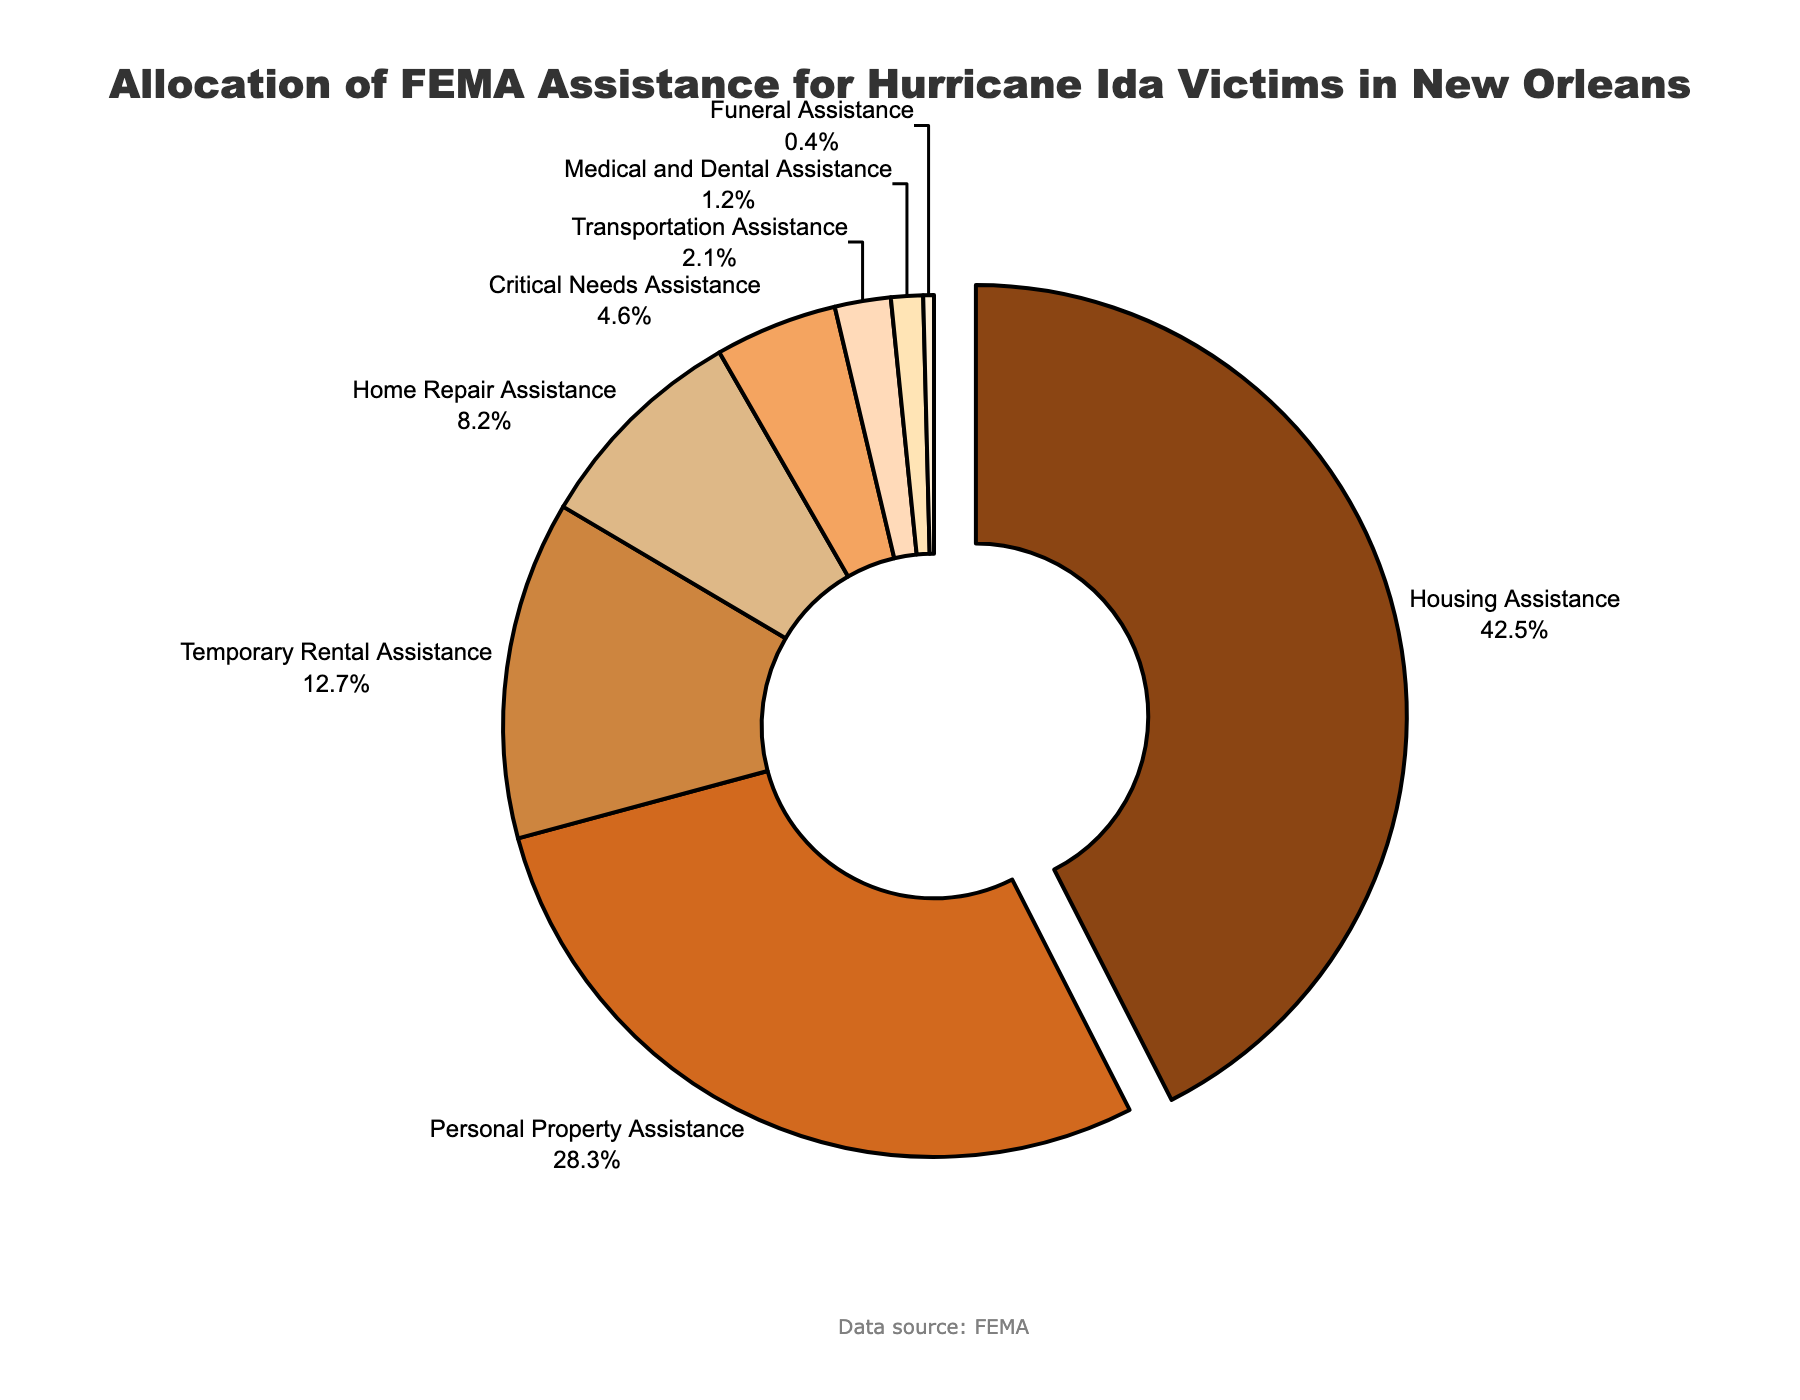What category receives the highest percentage of FEMA assistance? According to the pie chart, the segment with the highest percentage is labeled "Housing Assistance."
Answer: Housing Assistance How much more percentage of FEMA assistance does Personal Property Assistance receive compared to Home Repair Assistance? From the chart, Personal Property Assistance receives 28.3%, and Home Repair Assistance receives 8.2%. The difference is calculated as 28.3 - 8.2 = 20.1.
Answer: 20.1% Which category receives the least amount of FEMA assistance? The smallest segment in the pie chart is labeled "Funeral Assistance."
Answer: Funeral Assistance What is the total percentage allocated to Temporary Rental Assistance, Transportation Assistance, and Medical and Dental Assistance combined? Adding the percentages of these categories: Temporary Rental Assistance (12.7%) + Transportation Assistance (2.1%) + Medical and Dental Assistance (1.2%) yields 12.7 + 2.1 + 1.2 = 16.0.
Answer: 16.0% Is the percentage of assistance for Critical Needs Assistance greater than the percentage for Transportation Assistance? Critical Needs Assistance is 4.6%, and Transportation Assistance is 2.1%. Comparing these, 4.6 is greater than 2.1.
Answer: Yes Which segment is visually "pulled away" from the rest of the pie chart? The segment pulled away is visually shown to be "Housing Assistance."
Answer: Housing Assistance What is the difference in percentage allocation between the two largest categories? The two largest categories are Housing Assistance (42.5%) and Personal Property Assistance (28.3%). The difference is 42.5 - 28.3 = 14.2.
Answer: 14.2% What is the sum percentage of assistance given to Housing Assistance and Home Repair Assistance? Adding the percentages of Housing Assistance (42.5%) and Home Repair Assistance (8.2%) gives 42.5 + 8.2 = 50.7.
Answer: 50.7% Are Medical and Dental Assistance and Funeral Assistance allocated more than 2% combined? Adding Medical and Dental Assistance (1.2%) and Funeral Assistance (0.4%) gives 1.2 + 0.4 = 1.6, which is less than 2%.
Answer: No What color represents Critical Needs Assistance on the pie chart? In the pie chart, Critical Needs Assistance is represented with a color from the light brown/beige range.
Answer: Light brown/beige 